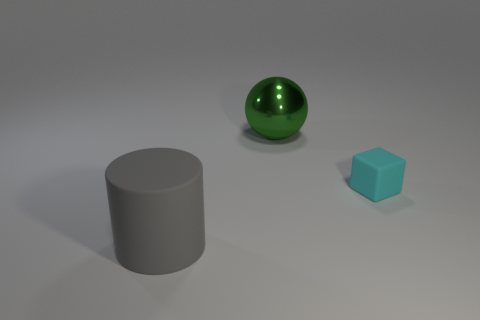Is there any other thing that is the same size as the green object? Yes, the blue cube appears to be roughly the same width and height as the diameter of the green sphere. 